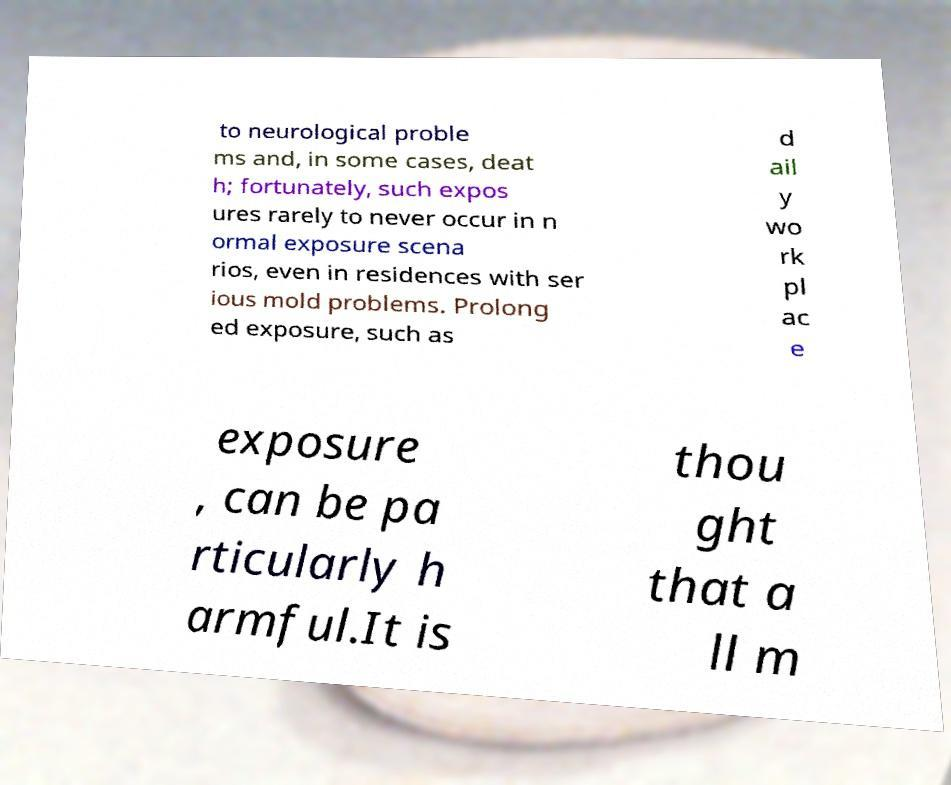What messages or text are displayed in this image? I need them in a readable, typed format. to neurological proble ms and, in some cases, deat h; fortunately, such expos ures rarely to never occur in n ormal exposure scena rios, even in residences with ser ious mold problems. Prolong ed exposure, such as d ail y wo rk pl ac e exposure , can be pa rticularly h armful.It is thou ght that a ll m 